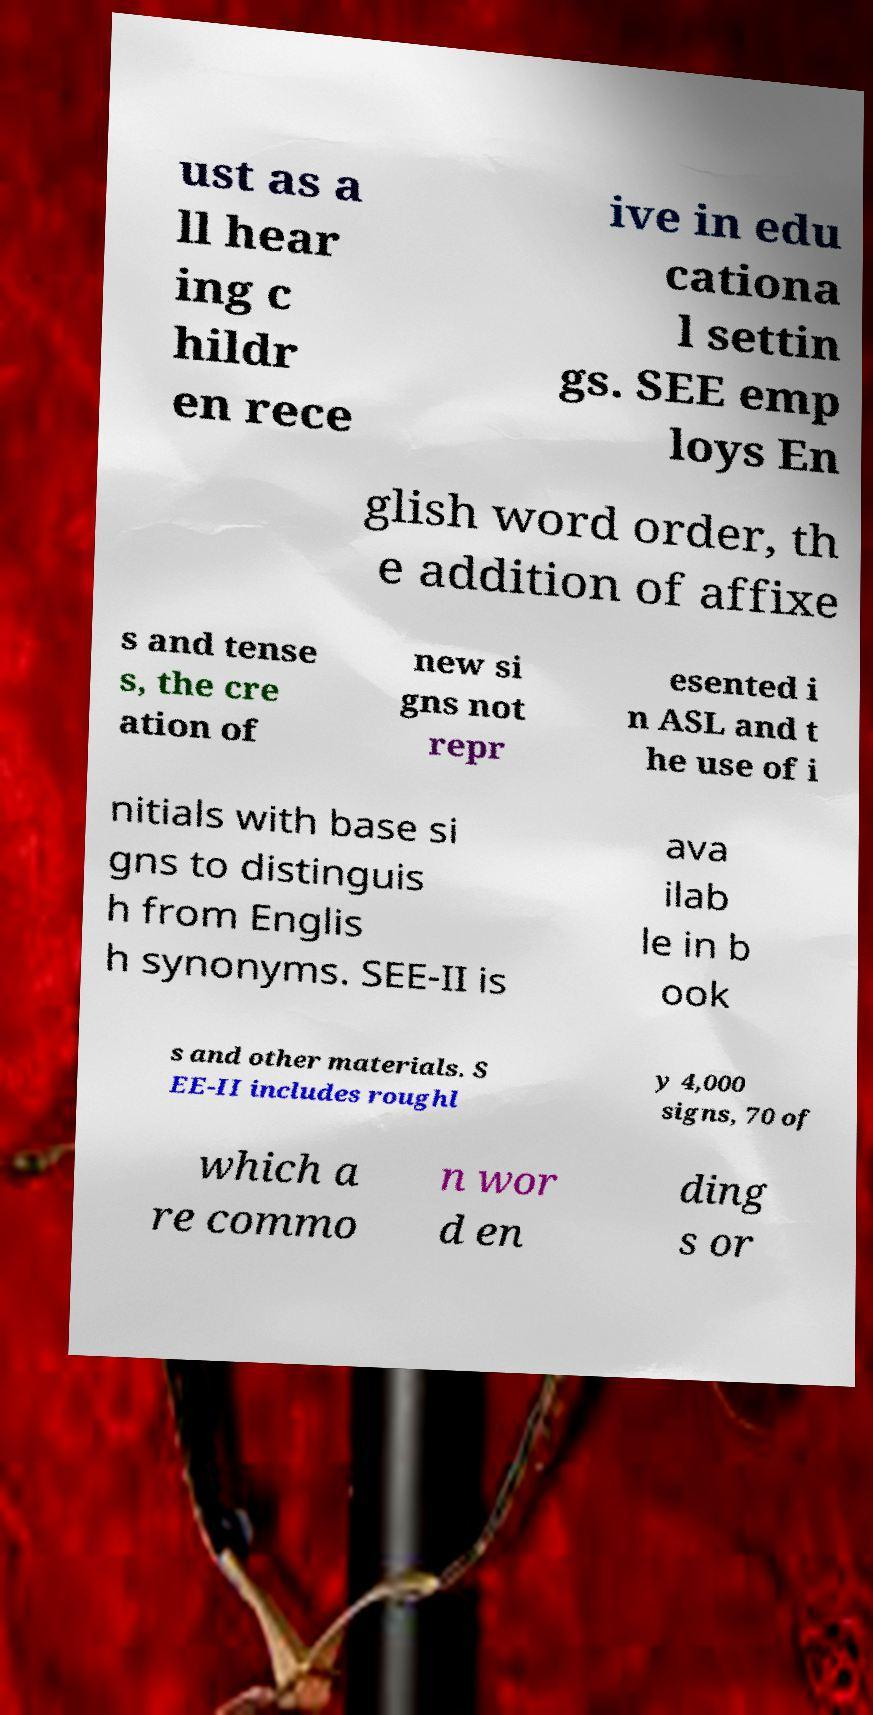I need the written content from this picture converted into text. Can you do that? ust as a ll hear ing c hildr en rece ive in edu cationa l settin gs. SEE emp loys En glish word order, th e addition of affixe s and tense s, the cre ation of new si gns not repr esented i n ASL and t he use of i nitials with base si gns to distinguis h from Englis h synonyms. SEE-II is ava ilab le in b ook s and other materials. S EE-II includes roughl y 4,000 signs, 70 of which a re commo n wor d en ding s or 